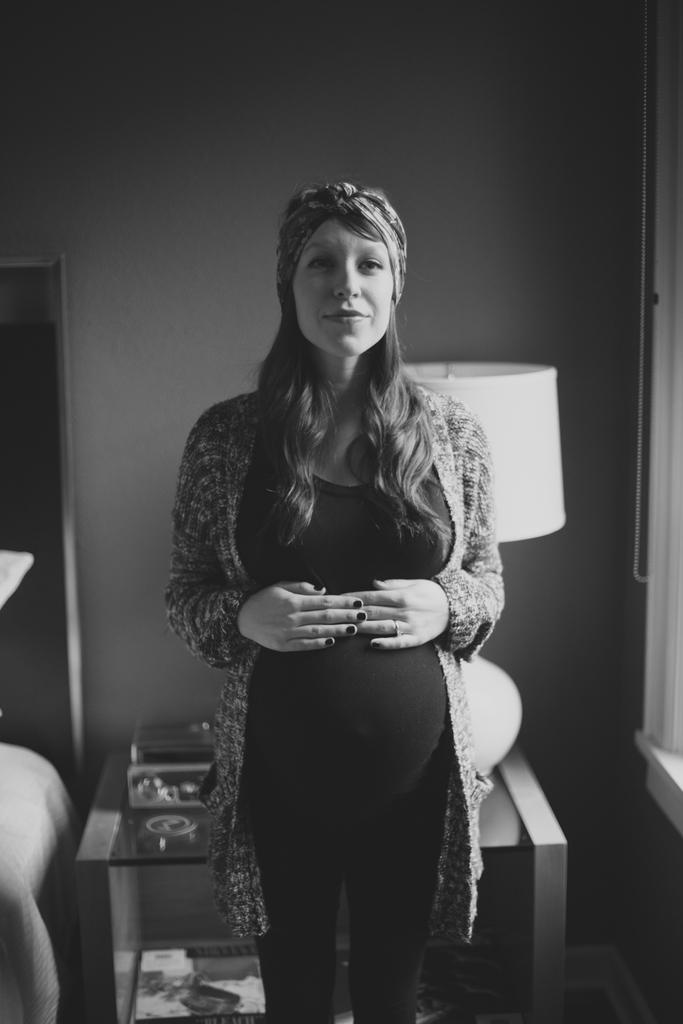Who is present in the image? There is a woman in the image. What is the woman doing in the image? The woman is standing. What can be seen in the background of the image? There is a table and a wall visible in the background of the image. What is on the table in the image? There is a lamp on the table. What type of cart is being used by the woman in the image? There is no cart present in the image; the woman is standing. What is the woman doing with her head in the image? The image does not show the woman doing anything specific with her head. 